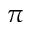<formula> <loc_0><loc_0><loc_500><loc_500>\pi</formula> 